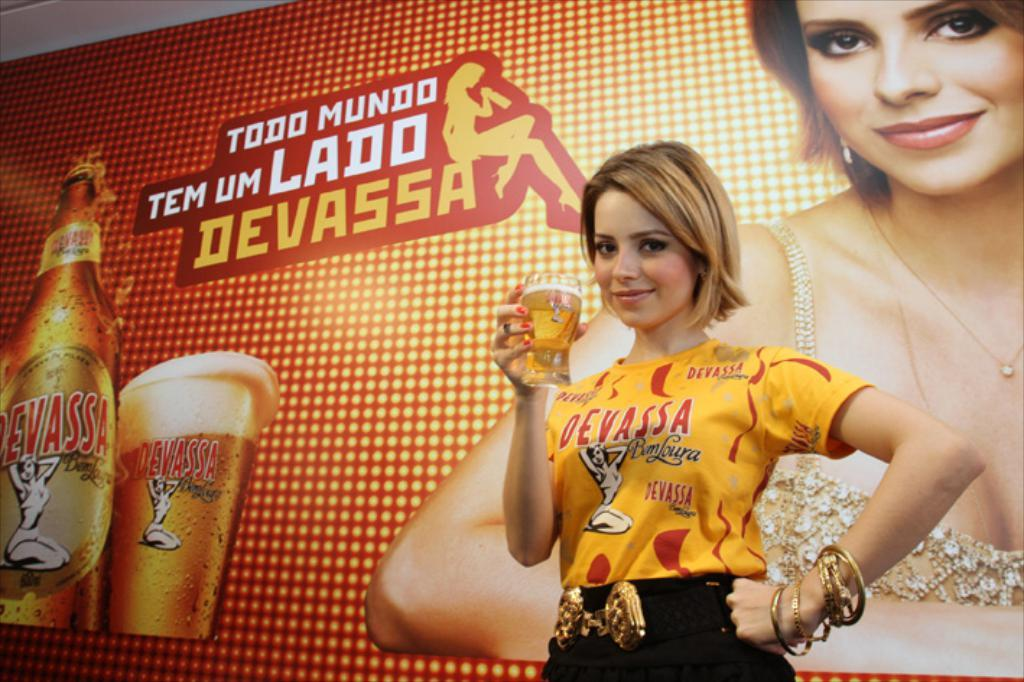Who is present in the image? There is a woman in the image. What is the woman holding in her hand? The woman is holding a glass in her hand. What is the woman wearing? The woman is wearing a yellow t-shirt. What is the woman's facial expression? The woman is smiling. What can be seen in the background of the image? There is an advertisement board in the background of the image. What type of instrument is the woman playing in the image? There is no instrument present in the image, and the woman is not playing any instrument. 